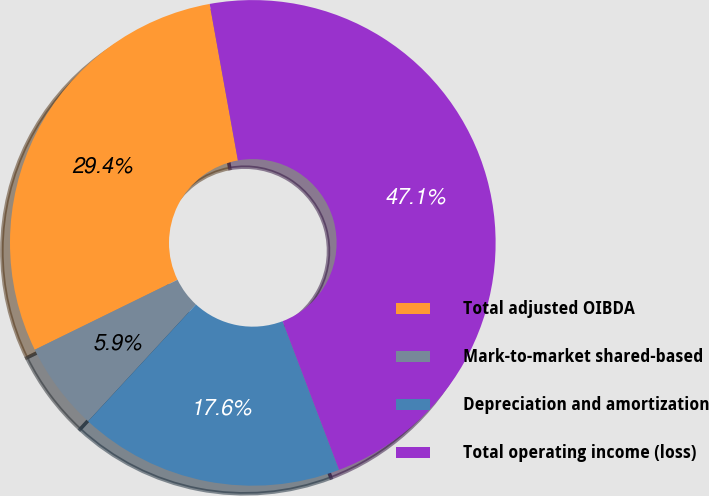Convert chart to OTSL. <chart><loc_0><loc_0><loc_500><loc_500><pie_chart><fcel>Total adjusted OIBDA<fcel>Mark-to-market shared-based<fcel>Depreciation and amortization<fcel>Total operating income (loss)<nl><fcel>29.41%<fcel>5.88%<fcel>17.65%<fcel>47.06%<nl></chart> 